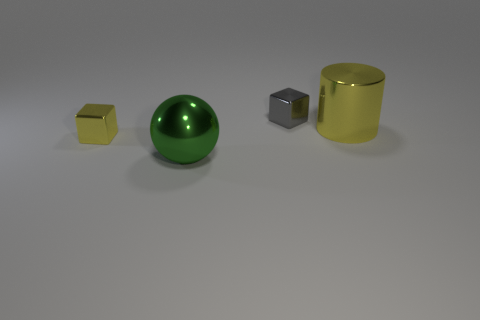There is a yellow cylinder; is it the same size as the yellow metallic object left of the ball?
Keep it short and to the point. No. Is there a big shiny block that has the same color as the shiny cylinder?
Your answer should be very brief. No. There is a green object that is the same material as the tiny gray cube; what is its size?
Provide a succinct answer. Large. Are the big green ball and the yellow cylinder made of the same material?
Your response must be concise. Yes. What is the color of the shiny block that is left of the small metal object that is on the right side of the yellow object that is in front of the large shiny cylinder?
Make the answer very short. Yellow. What is the shape of the green thing?
Your response must be concise. Sphere. Do the cylinder and the small metallic object that is on the right side of the green shiny thing have the same color?
Provide a short and direct response. No. Are there an equal number of big green objects that are behind the yellow metal block and tiny green shiny things?
Your answer should be compact. Yes. What number of yellow objects are the same size as the sphere?
Offer a very short reply. 1. There is a tiny shiny thing that is the same color as the big metallic cylinder; what shape is it?
Keep it short and to the point. Cube. 